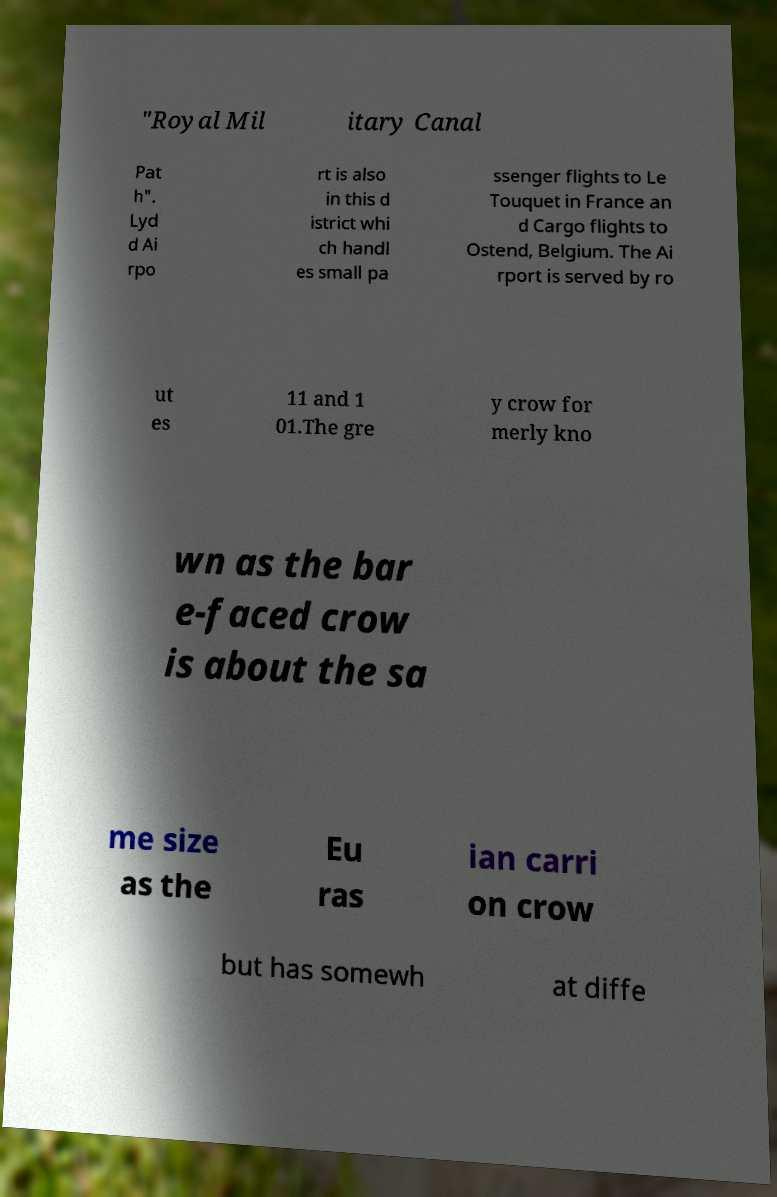Can you read and provide the text displayed in the image?This photo seems to have some interesting text. Can you extract and type it out for me? "Royal Mil itary Canal Pat h". Lyd d Ai rpo rt is also in this d istrict whi ch handl es small pa ssenger flights to Le Touquet in France an d Cargo flights to Ostend, Belgium. The Ai rport is served by ro ut es 11 and 1 01.The gre y crow for merly kno wn as the bar e-faced crow is about the sa me size as the Eu ras ian carri on crow but has somewh at diffe 